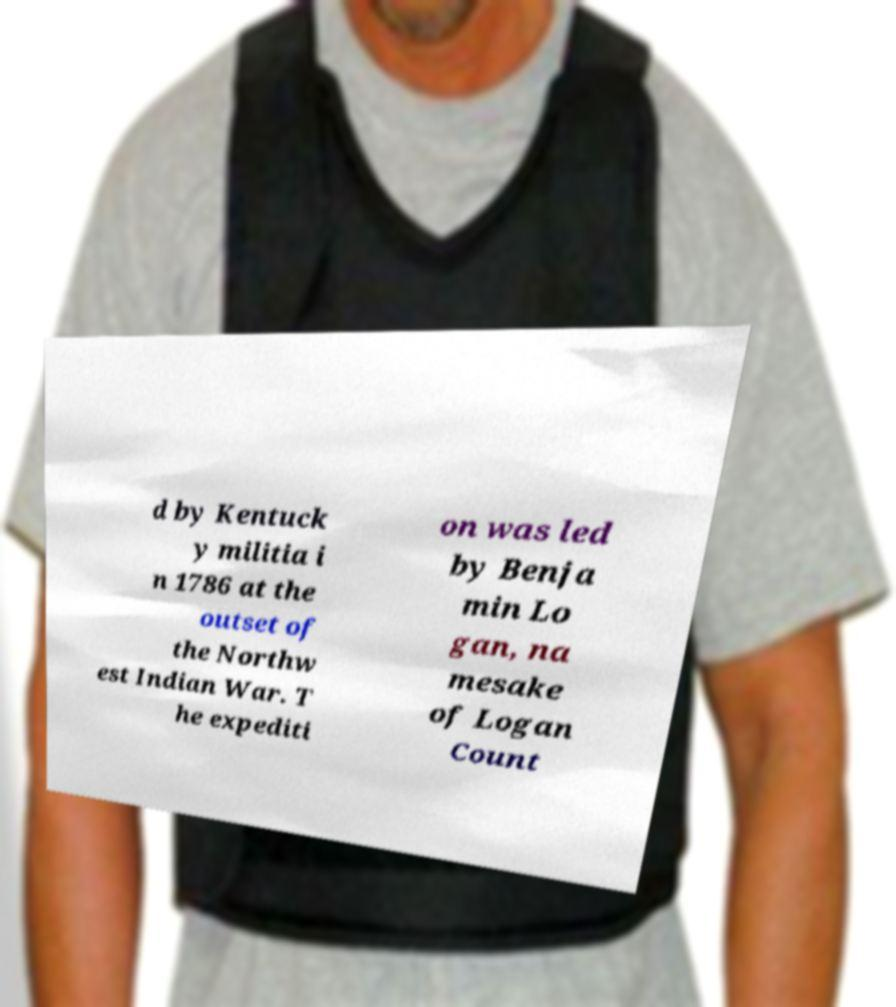Can you read and provide the text displayed in the image?This photo seems to have some interesting text. Can you extract and type it out for me? d by Kentuck y militia i n 1786 at the outset of the Northw est Indian War. T he expediti on was led by Benja min Lo gan, na mesake of Logan Count 